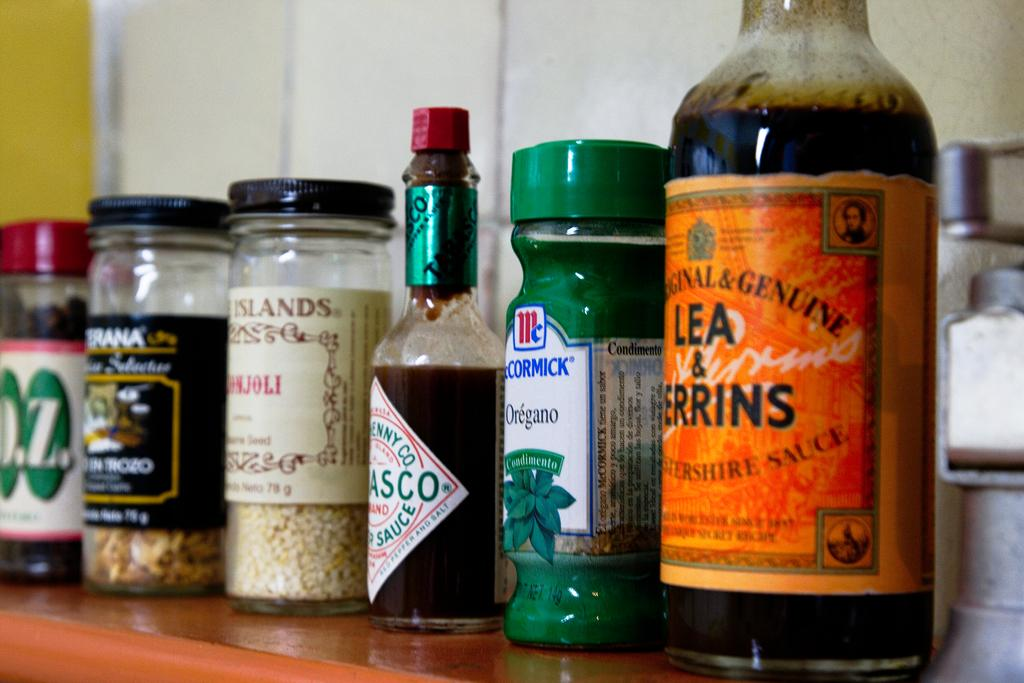What objects can be seen on the table in the image? There are different bottles on a table in the image. What information can be gathered from the bottles? There are labels on the bottles, which provide information about their contents. What can be found inside the bottles? There are items inside the bottles, as indicated by the labels. What type of hill can be seen in the background of the image? There is no hill visible in the image; it only features bottles on a table. 